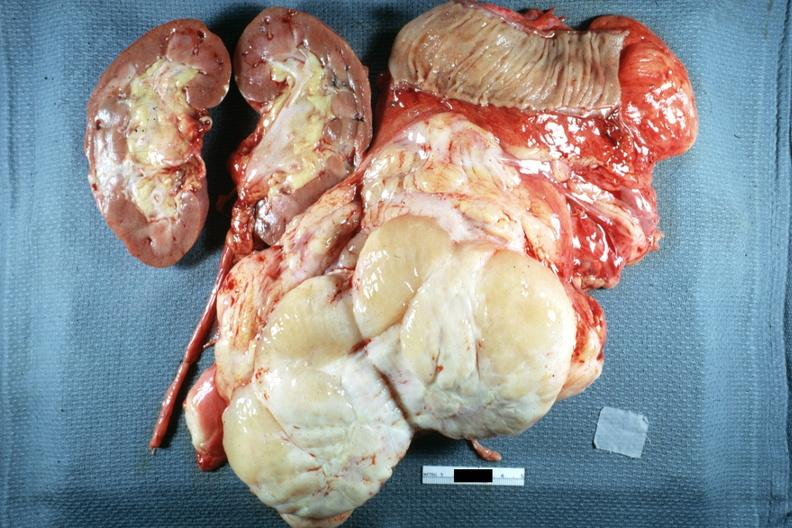what does this image show?
Answer the question using a single word or phrase. Whole tumor with kidney and portion of jejunum resected surgically cut surface shows typical fish flesh and yellow sarcoma 